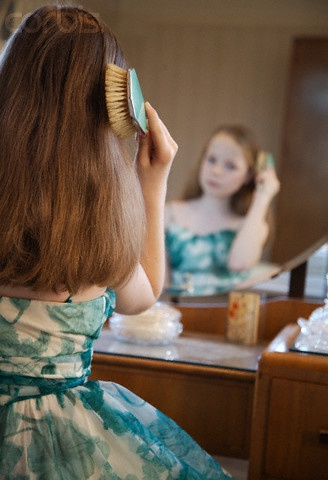Describe the objects in this image and their specific colors. I can see people in black, maroon, gray, and darkgray tones and people in black, darkgray, teal, and gray tones in this image. 